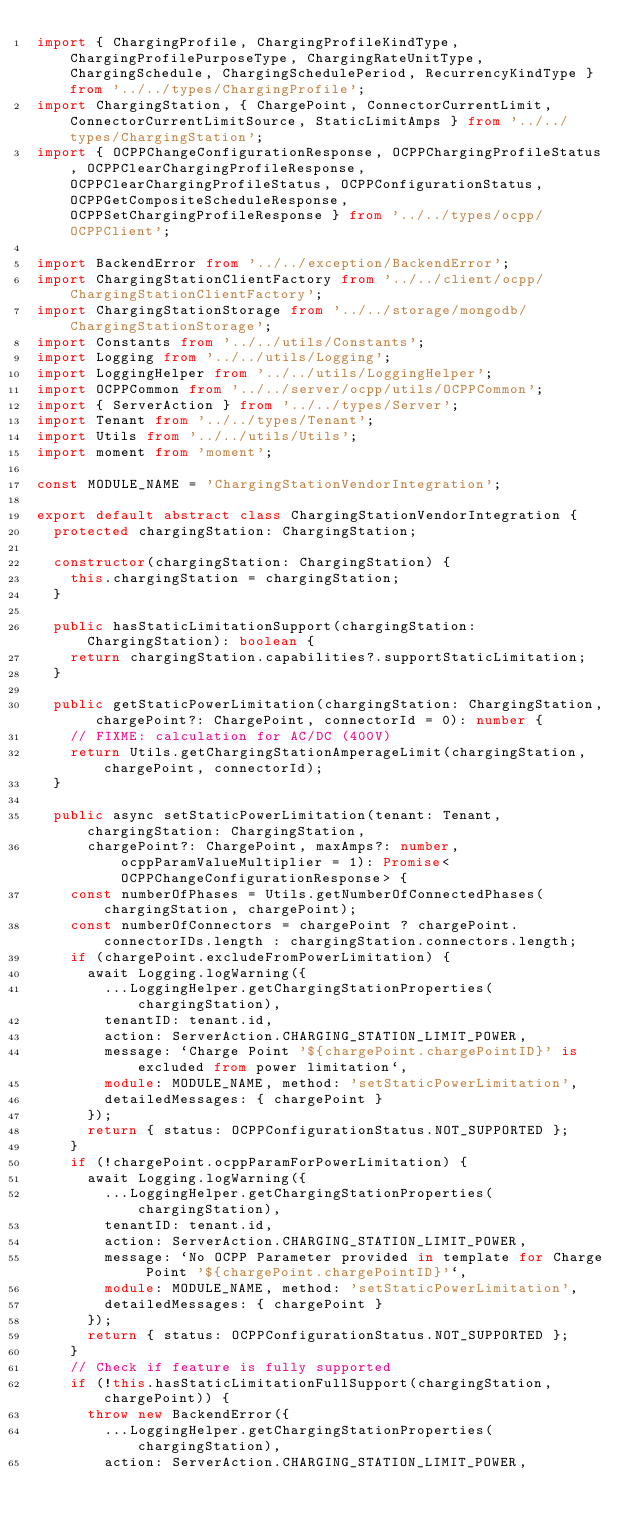<code> <loc_0><loc_0><loc_500><loc_500><_TypeScript_>import { ChargingProfile, ChargingProfileKindType, ChargingProfilePurposeType, ChargingRateUnitType, ChargingSchedule, ChargingSchedulePeriod, RecurrencyKindType } from '../../types/ChargingProfile';
import ChargingStation, { ChargePoint, ConnectorCurrentLimit, ConnectorCurrentLimitSource, StaticLimitAmps } from '../../types/ChargingStation';
import { OCPPChangeConfigurationResponse, OCPPChargingProfileStatus, OCPPClearChargingProfileResponse, OCPPClearChargingProfileStatus, OCPPConfigurationStatus, OCPPGetCompositeScheduleResponse, OCPPSetChargingProfileResponse } from '../../types/ocpp/OCPPClient';

import BackendError from '../../exception/BackendError';
import ChargingStationClientFactory from '../../client/ocpp/ChargingStationClientFactory';
import ChargingStationStorage from '../../storage/mongodb/ChargingStationStorage';
import Constants from '../../utils/Constants';
import Logging from '../../utils/Logging';
import LoggingHelper from '../../utils/LoggingHelper';
import OCPPCommon from '../../server/ocpp/utils/OCPPCommon';
import { ServerAction } from '../../types/Server';
import Tenant from '../../types/Tenant';
import Utils from '../../utils/Utils';
import moment from 'moment';

const MODULE_NAME = 'ChargingStationVendorIntegration';

export default abstract class ChargingStationVendorIntegration {
  protected chargingStation: ChargingStation;

  constructor(chargingStation: ChargingStation) {
    this.chargingStation = chargingStation;
  }

  public hasStaticLimitationSupport(chargingStation: ChargingStation): boolean {
    return chargingStation.capabilities?.supportStaticLimitation;
  }

  public getStaticPowerLimitation(chargingStation: ChargingStation, chargePoint?: ChargePoint, connectorId = 0): number {
    // FIXME: calculation for AC/DC (400V)
    return Utils.getChargingStationAmperageLimit(chargingStation, chargePoint, connectorId);
  }

  public async setStaticPowerLimitation(tenant: Tenant, chargingStation: ChargingStation,
      chargePoint?: ChargePoint, maxAmps?: number, ocppParamValueMultiplier = 1): Promise<OCPPChangeConfigurationResponse> {
    const numberOfPhases = Utils.getNumberOfConnectedPhases(chargingStation, chargePoint);
    const numberOfConnectors = chargePoint ? chargePoint.connectorIDs.length : chargingStation.connectors.length;
    if (chargePoint.excludeFromPowerLimitation) {
      await Logging.logWarning({
        ...LoggingHelper.getChargingStationProperties(chargingStation),
        tenantID: tenant.id,
        action: ServerAction.CHARGING_STATION_LIMIT_POWER,
        message: `Charge Point '${chargePoint.chargePointID}' is excluded from power limitation`,
        module: MODULE_NAME, method: 'setStaticPowerLimitation',
        detailedMessages: { chargePoint }
      });
      return { status: OCPPConfigurationStatus.NOT_SUPPORTED };
    }
    if (!chargePoint.ocppParamForPowerLimitation) {
      await Logging.logWarning({
        ...LoggingHelper.getChargingStationProperties(chargingStation),
        tenantID: tenant.id,
        action: ServerAction.CHARGING_STATION_LIMIT_POWER,
        message: `No OCPP Parameter provided in template for Charge Point '${chargePoint.chargePointID}'`,
        module: MODULE_NAME, method: 'setStaticPowerLimitation',
        detailedMessages: { chargePoint }
      });
      return { status: OCPPConfigurationStatus.NOT_SUPPORTED };
    }
    // Check if feature is fully supported
    if (!this.hasStaticLimitationFullSupport(chargingStation, chargePoint)) {
      throw new BackendError({
        ...LoggingHelper.getChargingStationProperties(chargingStation),
        action: ServerAction.CHARGING_STATION_LIMIT_POWER,</code> 